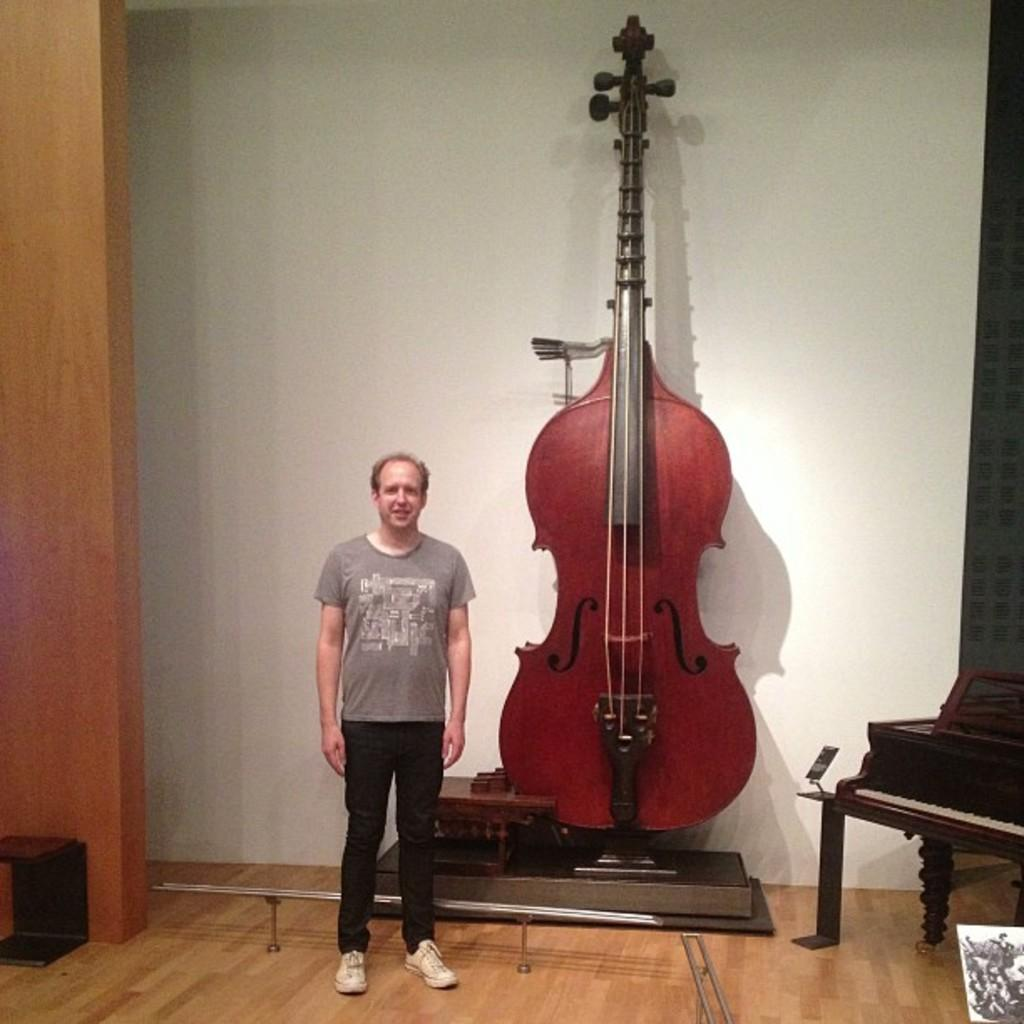What is the man in the image doing? The man is standing in the image. What is the man standing beside in the image? The man is beside a giant violin. What color is the man's T-shirt in the image? The man is wearing an ash-colored T-shirt. What type of pants is the man wearing in the image? The man is wearing black pants. What type of shoes is the man wearing in the image? The man is wearing casual shoes. What type of net is being used by the committee in the image? There is no committee or net present in the image; it features a man standing beside a giant violin. 